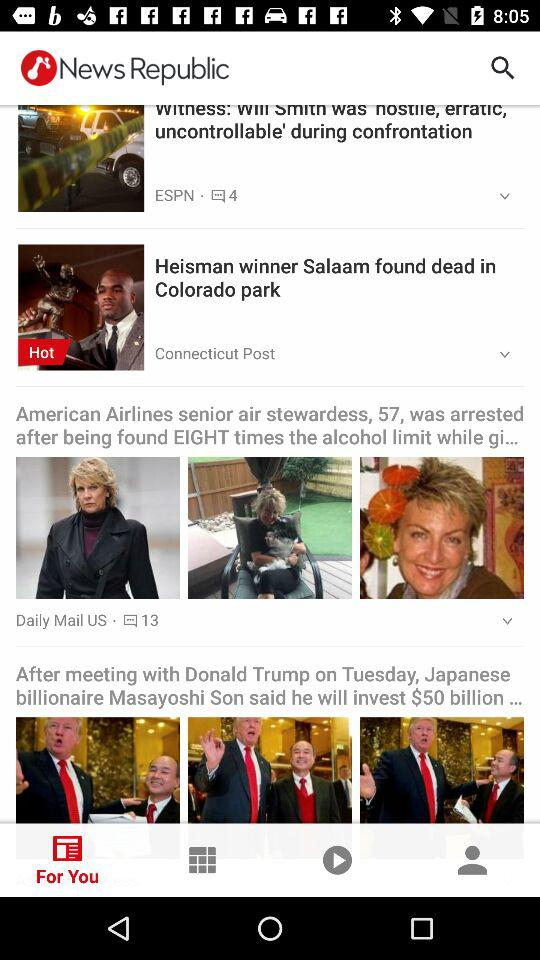How many stories are about American Airlines?
Answer the question using a single word or phrase. 1 